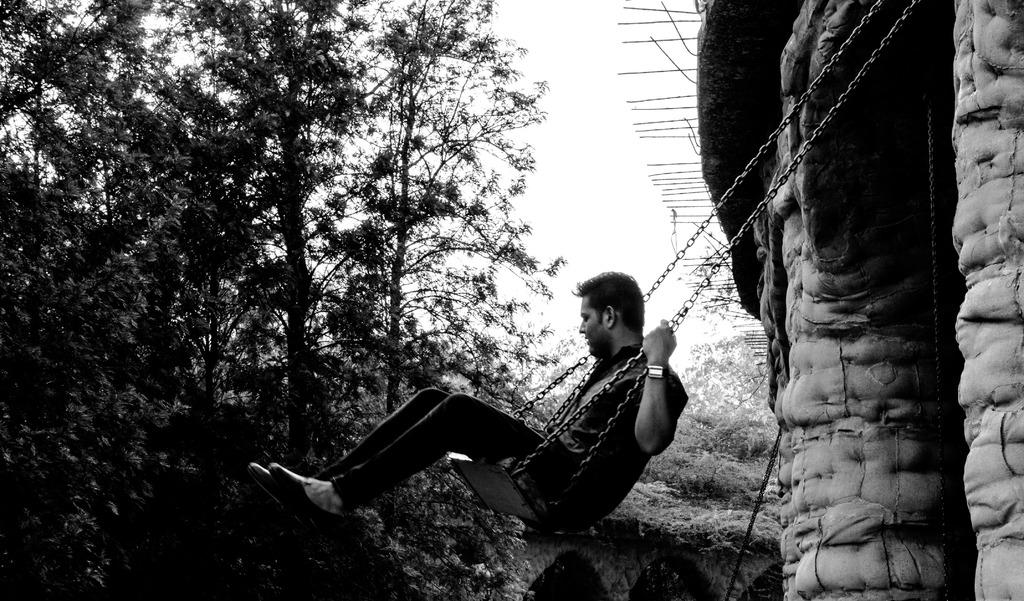What type of image is this? The image is a black and white photography. Who or what is the main subject in the image? There is a man in the image. What is the man doing in the image? The man is sitting on a swing chair and swinging. What can be seen in the background of the image? There is a wall, a roof, and trees in the background of the image. What type of drain is visible in the image? There is no drain present in the image. How many cushions are on the swing chair in the image? The image is in black and white, and there is no indication of cushions on the swing chair. 